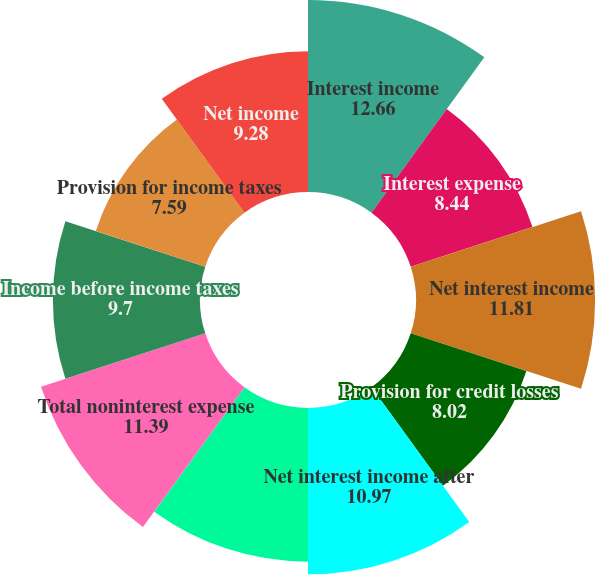<chart> <loc_0><loc_0><loc_500><loc_500><pie_chart><fcel>Interest income<fcel>Interest expense<fcel>Net interest income<fcel>Provision for credit losses<fcel>Net interest income after<fcel>Total noninterest income<fcel>Total noninterest expense<fcel>Income before income taxes<fcel>Provision for income taxes<fcel>Net income<nl><fcel>12.66%<fcel>8.44%<fcel>11.81%<fcel>8.02%<fcel>10.97%<fcel>10.13%<fcel>11.39%<fcel>9.7%<fcel>7.59%<fcel>9.28%<nl></chart> 